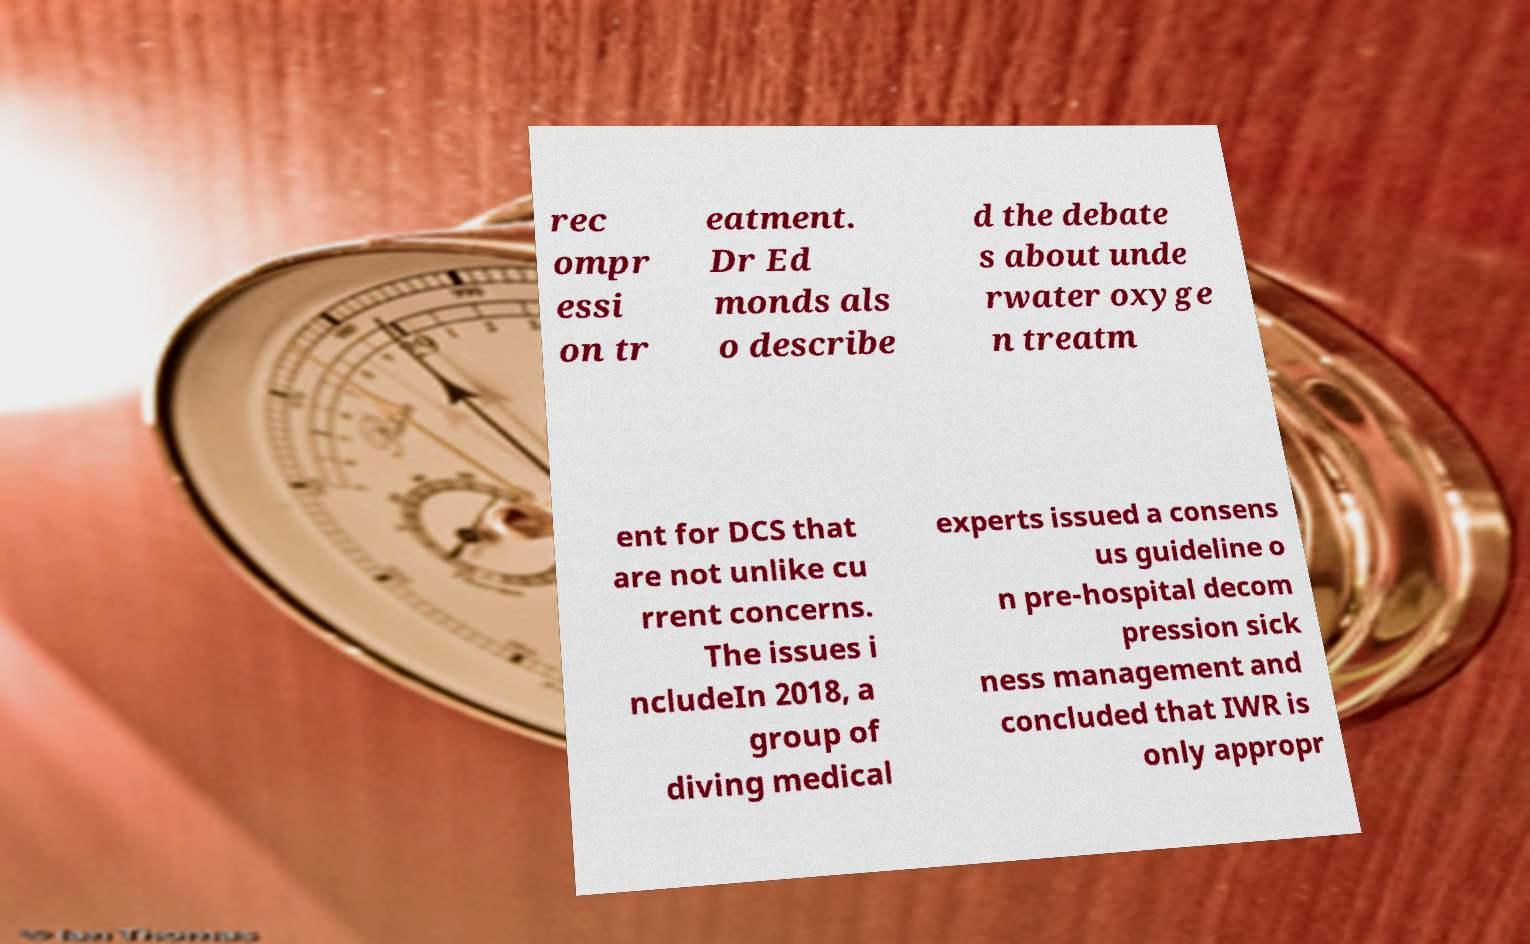Please read and relay the text visible in this image. What does it say? rec ompr essi on tr eatment. Dr Ed monds als o describe d the debate s about unde rwater oxyge n treatm ent for DCS that are not unlike cu rrent concerns. The issues i ncludeIn 2018, a group of diving medical experts issued a consens us guideline o n pre-hospital decom pression sick ness management and concluded that IWR is only appropr 